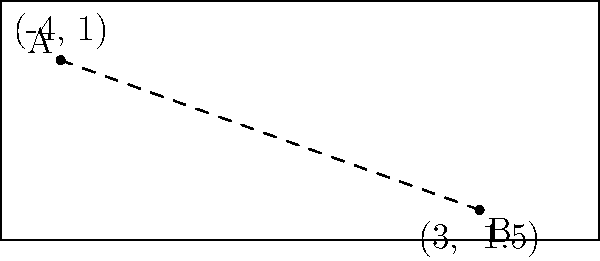On a curling sheet, two strategic points A(-4, 1) and B(3, -1.5) have been identified. Using the distance formula, calculate the distance between these two points. Round your answer to two decimal places. To find the distance between two points, we'll use the distance formula:

$$d = \sqrt{(x_2 - x_1)^2 + (y_2 - y_1)^2}$$

Where $(x_1, y_1)$ are the coordinates of point A, and $(x_2, y_2)$ are the coordinates of point B.

Step 1: Identify the coordinates
A: $(-4, 1)$
B: $(3, -1.5)$

Step 2: Plug the values into the formula
$$d = \sqrt{(3 - (-4))^2 + (-1.5 - 1)^2}$$

Step 3: Simplify inside the parentheses
$$d = \sqrt{(3 + 4)^2 + (-2.5)^2}$$
$$d = \sqrt{7^2 + (-2.5)^2}$$

Step 4: Calculate the squares
$$d = \sqrt{49 + 6.25}$$

Step 5: Add under the square root
$$d = \sqrt{55.25}$$

Step 6: Calculate the square root and round to two decimal places
$$d \approx 7.43$$

Therefore, the distance between points A and B on the curling sheet is approximately 7.43 units.
Answer: 7.43 units 